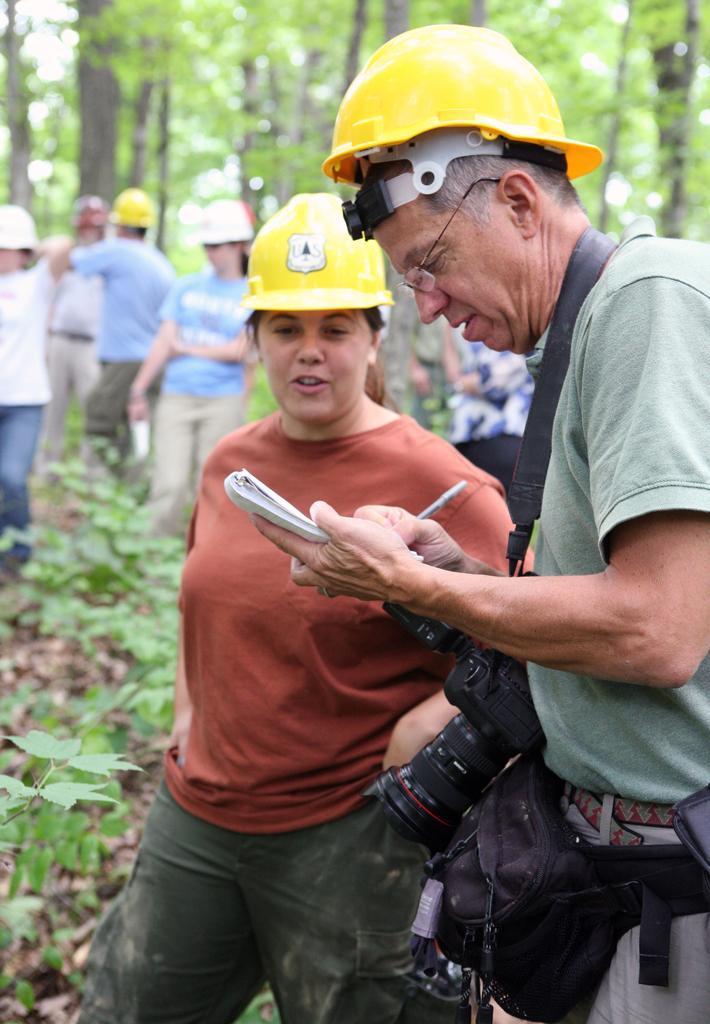Can you describe this image briefly? In this picture I can see in the middle a woman is there, on the right side there is a man, he is wearing a camera and writing on a book. In the background there are people, they are wearing helmets and there are trees. On the left side there are plants. 